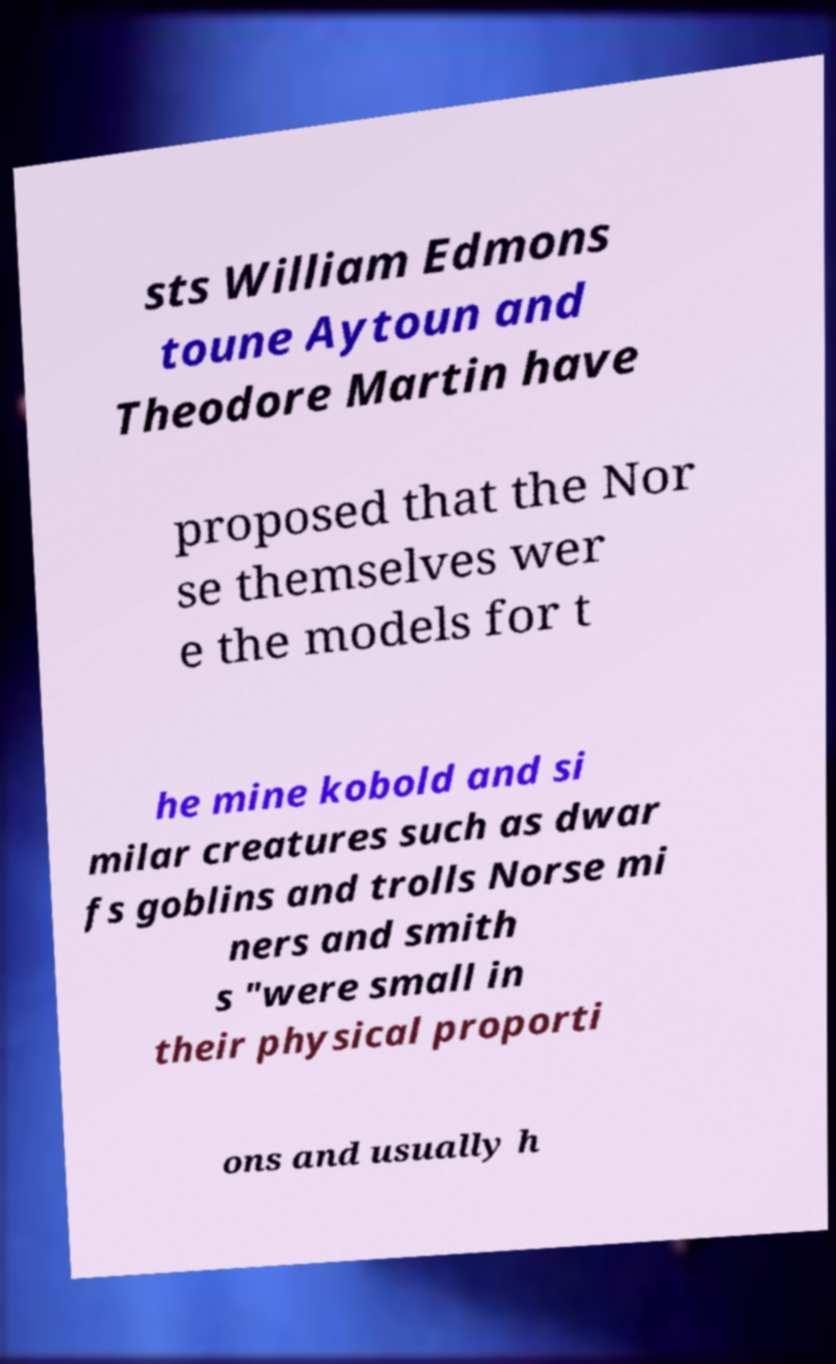Please identify and transcribe the text found in this image. sts William Edmons toune Aytoun and Theodore Martin have proposed that the Nor se themselves wer e the models for t he mine kobold and si milar creatures such as dwar fs goblins and trolls Norse mi ners and smith s "were small in their physical proporti ons and usually h 